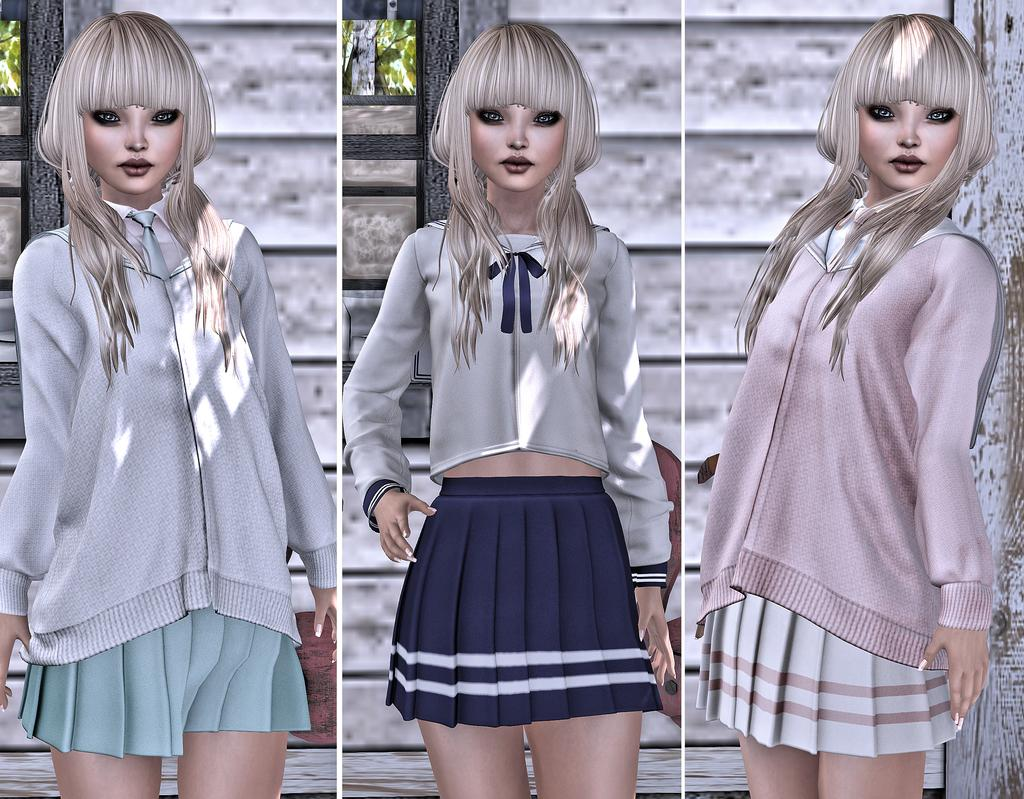How many collage photos are present in the image? There are three collage photos in the image. What do the collage photos contain? The collage photos contain edited images of dolls. What type of wall can be seen in the background of the image? There is a wooden panel wall in the background of the image. What is the chance of winning a soda in the park, as depicted in the image? There is no reference to a park or winning a soda in the image; it features three collage photos with edited images of dolls and a wooden panel wall in the background. 